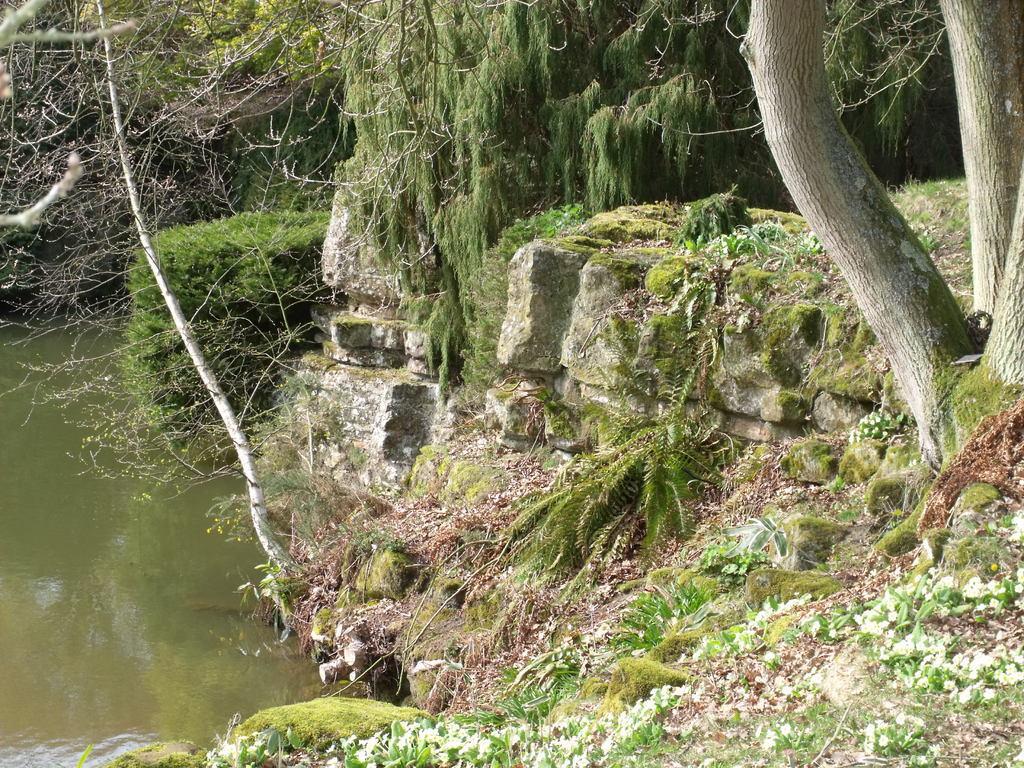Can you describe this image briefly? In this image, I can see the rocks, trees and plants. On the left side of the image, there is water. 